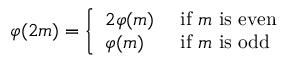Convert formula to latex. <formula><loc_0><loc_0><loc_500><loc_500>\varphi ( 2 m ) = { \left \{ \begin{array} { l l } { 2 \varphi ( m ) } & { { i f } m { i s e v e n } } \\ { \varphi ( m ) } & { { i f } m { i s o d d } } \end{array} }</formula> 